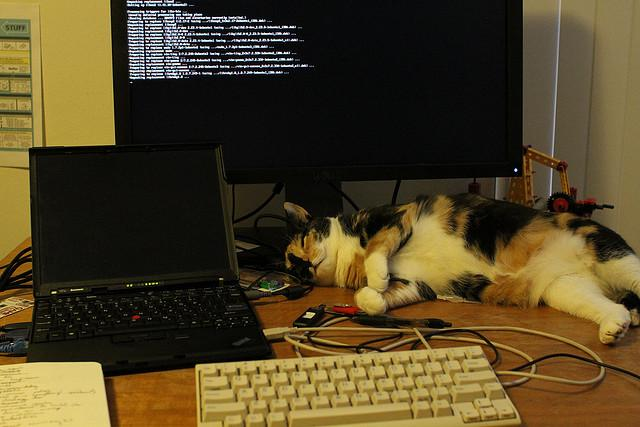What is the cat sleeping near?

Choices:
A) woman
B) baby
C) dog
D) computer computer 